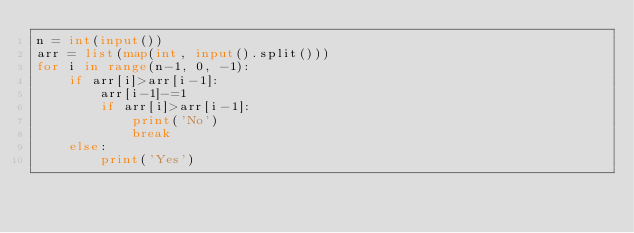<code> <loc_0><loc_0><loc_500><loc_500><_Python_>n = int(input())
arr = list(map(int, input().split()))
for i in range(n-1, 0, -1):
    if arr[i]>arr[i-1]:
        arr[i-1]-=1
        if arr[i]>arr[i-1]:
            print('No')
            break
    else:
        print('Yes')</code> 